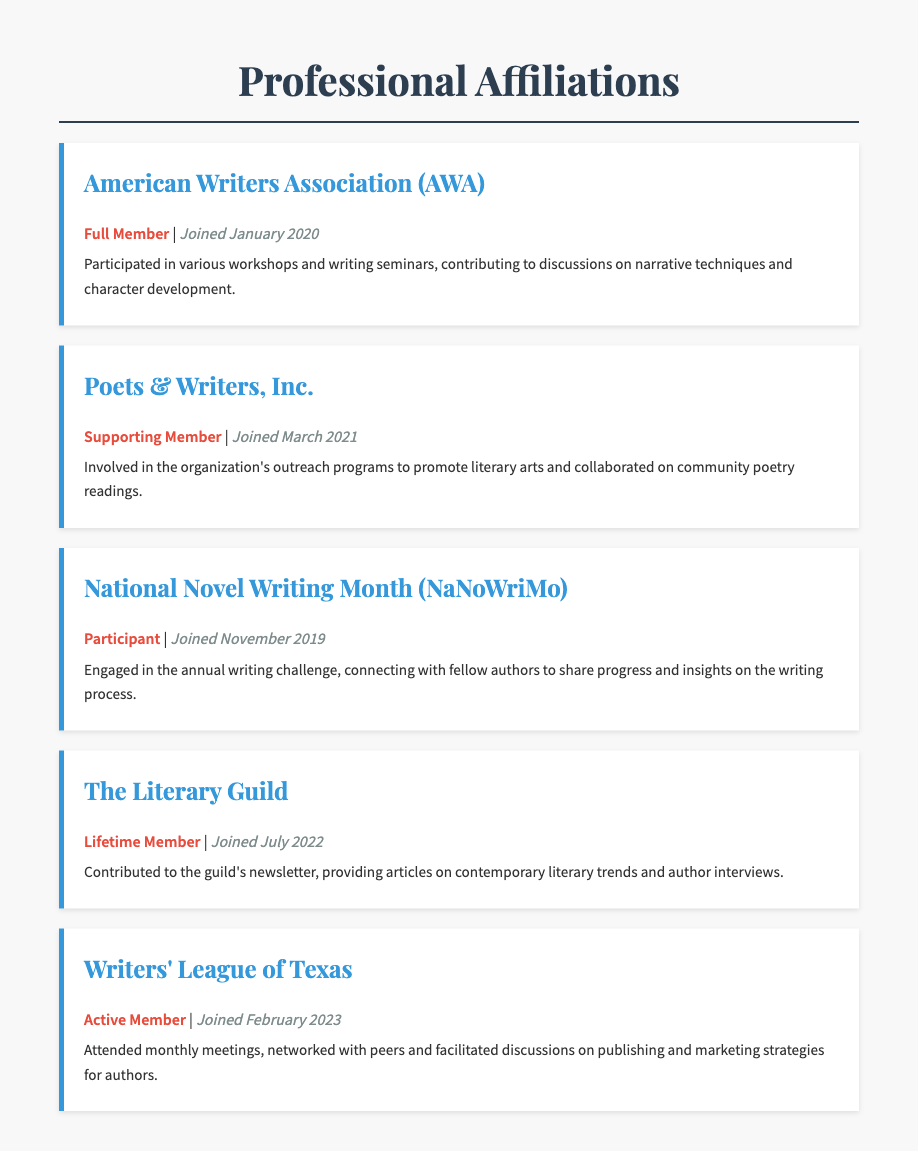what is the membership type for American Writers Association? The membership type for American Writers Association is specified as "Full Member".
Answer: Full Member when did the author join Poets & Writers, Inc.? The document states that the author joined Poets & Writers, Inc. in March 2021.
Answer: March 2021 what role did the author have in The Literary Guild? The author's role in The Literary Guild involved contributing to the guild's newsletter.
Answer: Contributed to the guild's newsletter how many organizations is the author a member of? By counting the listed affiliations, we find that the author is a member of five organizations in total.
Answer: Five what kind of member is the author in Writers' League of Texas? The document describes the author's status in Writers' League of Texas as "Active Member".
Answer: Active Member which organization does the author have a lifetime membership in? The organization in which the author has a lifetime membership is clearly stated as "The Literary Guild".
Answer: The Literary Guild what prompted the author to engage with fellow authors in NaNoWriMo? The author engaged with fellow authors in NaNoWriMo as part of an annual writing challenge that fosters connection and sharing.
Answer: Annual writing challenge when did the author join National Novel Writing Month? The author joined National Novel Writing Month in November 2019 according to the document.
Answer: November 2019 